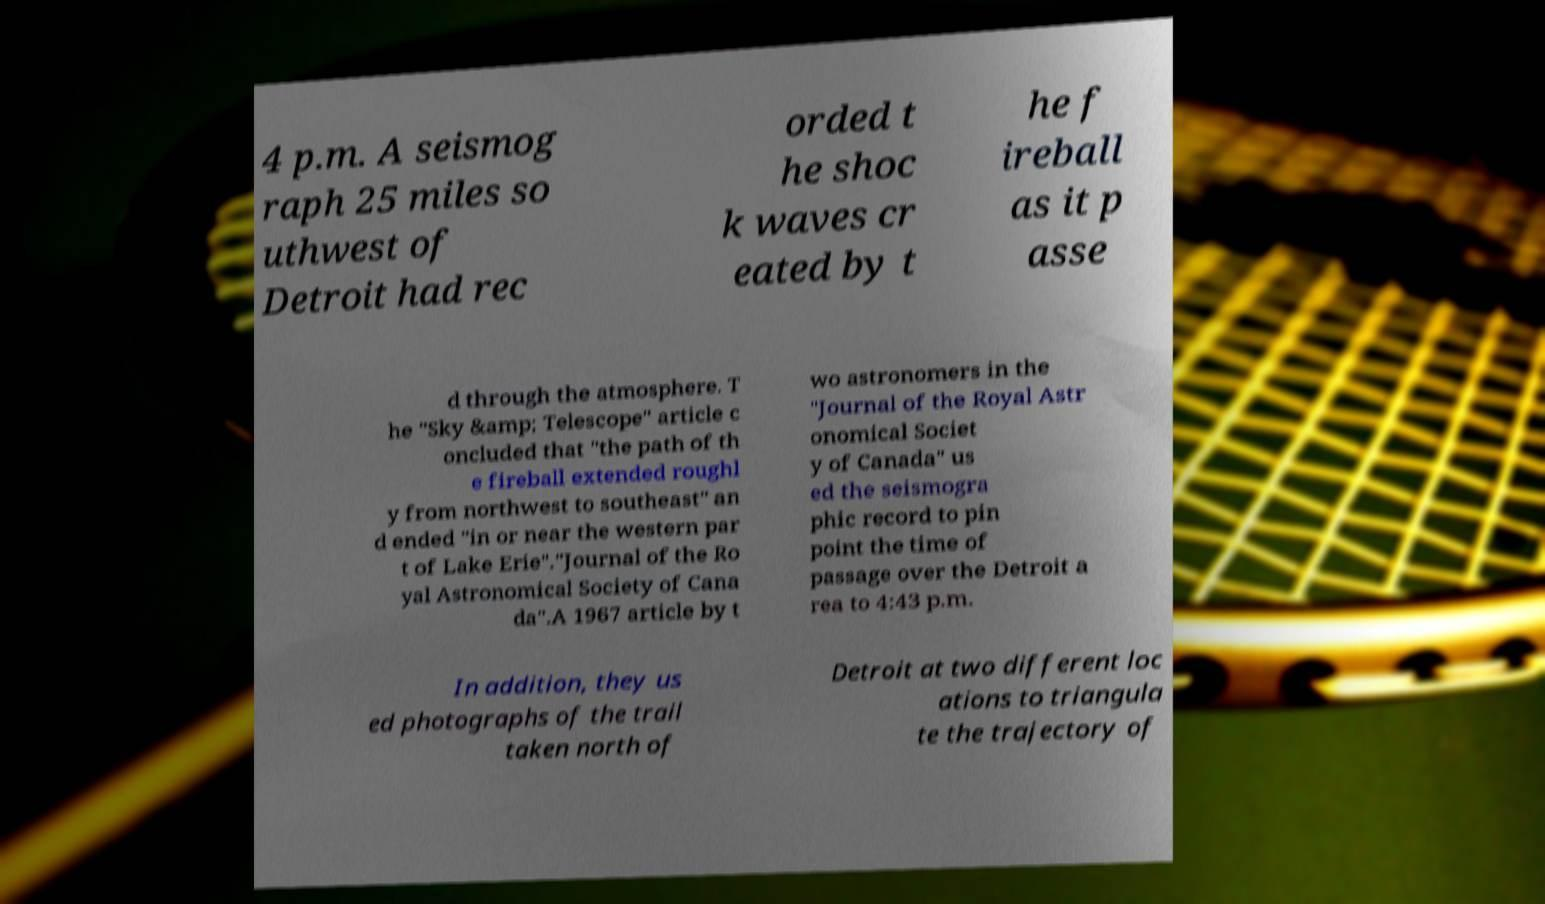What messages or text are displayed in this image? I need them in a readable, typed format. 4 p.m. A seismog raph 25 miles so uthwest of Detroit had rec orded t he shoc k waves cr eated by t he f ireball as it p asse d through the atmosphere. T he "Sky &amp; Telescope" article c oncluded that "the path of th e fireball extended roughl y from northwest to southeast" an d ended "in or near the western par t of Lake Erie"."Journal of the Ro yal Astronomical Society of Cana da".A 1967 article by t wo astronomers in the "Journal of the Royal Astr onomical Societ y of Canada" us ed the seismogra phic record to pin point the time of passage over the Detroit a rea to 4:43 p.m. In addition, they us ed photographs of the trail taken north of Detroit at two different loc ations to triangula te the trajectory of 